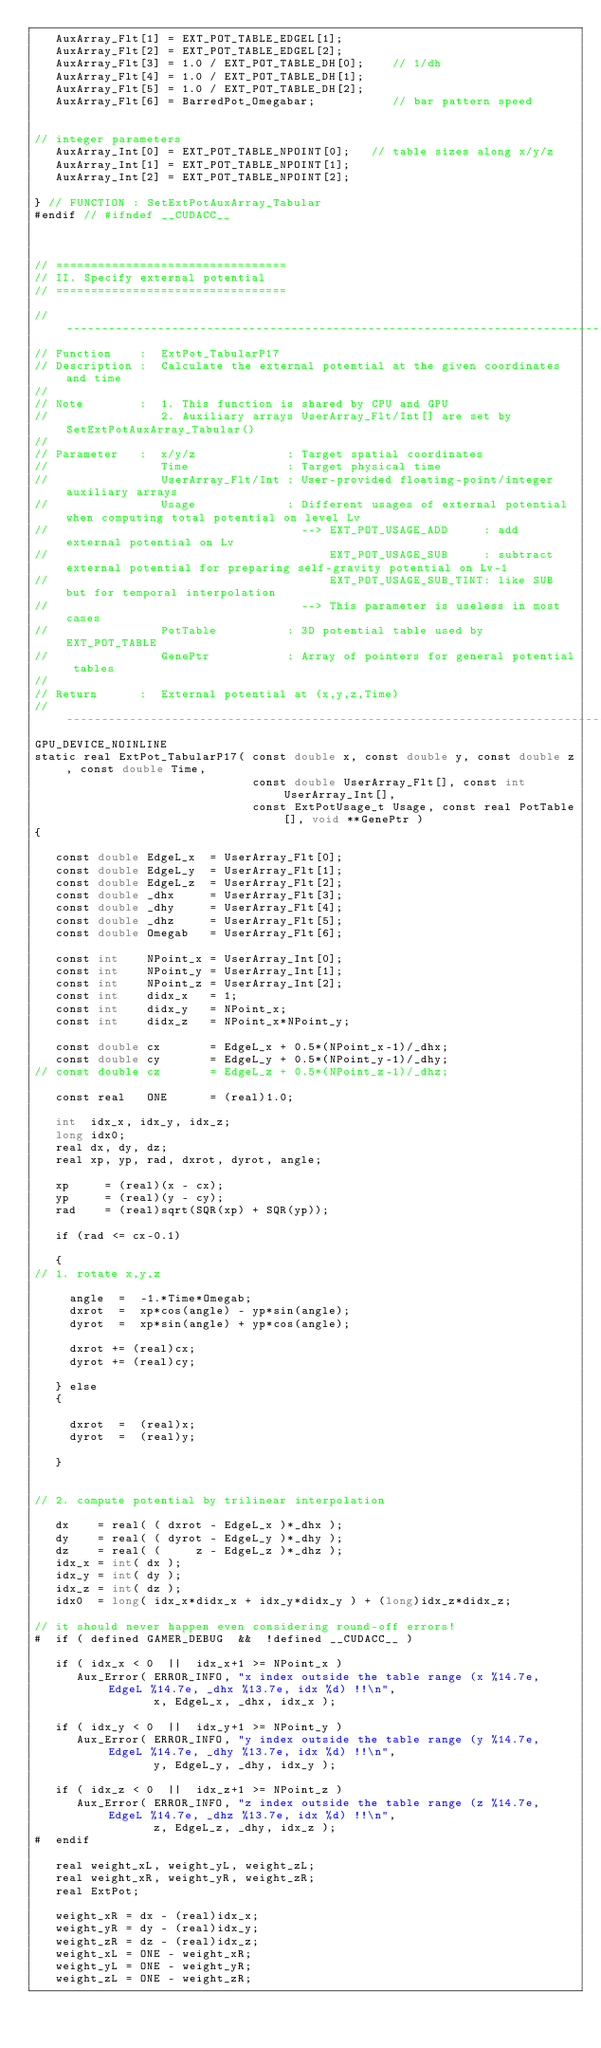Convert code to text. <code><loc_0><loc_0><loc_500><loc_500><_Cuda_>   AuxArray_Flt[1] = EXT_POT_TABLE_EDGEL[1];
   AuxArray_Flt[2] = EXT_POT_TABLE_EDGEL[2];
   AuxArray_Flt[3] = 1.0 / EXT_POT_TABLE_DH[0];    // 1/dh
   AuxArray_Flt[4] = 1.0 / EXT_POT_TABLE_DH[1];
   AuxArray_Flt[5] = 1.0 / EXT_POT_TABLE_DH[2];
   AuxArray_Flt[6] = BarredPot_Omegabar;           // bar pattern speed


// integer parameters
   AuxArray_Int[0] = EXT_POT_TABLE_NPOINT[0];   // table sizes along x/y/z
   AuxArray_Int[1] = EXT_POT_TABLE_NPOINT[1];
   AuxArray_Int[2] = EXT_POT_TABLE_NPOINT[2];

} // FUNCTION : SetExtPotAuxArray_Tabular
#endif // #ifndef __CUDACC__



// =================================
// II. Specify external potential
// =================================

//-----------------------------------------------------------------------------------------
// Function    :  ExtPot_TabularP17
// Description :  Calculate the external potential at the given coordinates and time
//
// Note        :  1. This function is shared by CPU and GPU
//                2. Auxiliary arrays UserArray_Flt/Int[] are set by SetExtPotAuxArray_Tabular()
//
// Parameter   :  x/y/z             : Target spatial coordinates
//                Time              : Target physical time
//                UserArray_Flt/Int : User-provided floating-point/integer auxiliary arrays
//                Usage             : Different usages of external potential when computing total potential on level Lv
//                                    --> EXT_POT_USAGE_ADD     : add external potential on Lv
//                                        EXT_POT_USAGE_SUB     : subtract external potential for preparing self-gravity potential on Lv-1
//                                        EXT_POT_USAGE_SUB_TINT: like SUB but for temporal interpolation
//                                    --> This parameter is useless in most cases
//                PotTable          : 3D potential table used by EXT_POT_TABLE
//                GenePtr           : Array of pointers for general potential tables
//
// Return      :  External potential at (x,y,z,Time)
//-----------------------------------------------------------------------------------------
GPU_DEVICE_NOINLINE
static real ExtPot_TabularP17( const double x, const double y, const double z, const double Time,
                               const double UserArray_Flt[], const int UserArray_Int[],
                               const ExtPotUsage_t Usage, const real PotTable[], void **GenePtr )
{

   const double EdgeL_x  = UserArray_Flt[0];
   const double EdgeL_y  = UserArray_Flt[1];
   const double EdgeL_z  = UserArray_Flt[2];
   const double _dhx     = UserArray_Flt[3];
   const double _dhy     = UserArray_Flt[4];
   const double _dhz     = UserArray_Flt[5];
   const double Omegab   = UserArray_Flt[6];

   const int    NPoint_x = UserArray_Int[0];
   const int    NPoint_y = UserArray_Int[1];
   const int    NPoint_z = UserArray_Int[2];
   const int    didx_x   = 1;
   const int    didx_y   = NPoint_x;
   const int    didx_z   = NPoint_x*NPoint_y;

   const double cx       = EdgeL_x + 0.5*(NPoint_x-1)/_dhx;
   const double cy       = EdgeL_y + 0.5*(NPoint_y-1)/_dhy;
// const double cz       = EdgeL_z + 0.5*(NPoint_z-1)/_dhz;

   const real   ONE      = (real)1.0;

   int  idx_x, idx_y, idx_z;
   long idx0;
   real dx, dy, dz;
   real xp, yp, rad, dxrot, dyrot, angle;

   xp     = (real)(x - cx);
   yp     = (real)(y - cy);
   rad    = (real)sqrt(SQR(xp) + SQR(yp));

   if (rad <= cx-0.1)

   {
// 1. rotate x,y,z

     angle  =  -1.*Time*Omegab;
     dxrot  =  xp*cos(angle) - yp*sin(angle);
     dyrot  =  xp*sin(angle) + yp*cos(angle);

     dxrot += (real)cx;
     dyrot += (real)cy;

   } else
   {

     dxrot  =  (real)x;
     dyrot  =  (real)y;

   }


// 2. compute potential by trilinear interpolation

   dx    = real( ( dxrot - EdgeL_x )*_dhx );
   dy    = real( ( dyrot - EdgeL_y )*_dhy );
   dz    = real( (     z - EdgeL_z )*_dhz );
   idx_x = int( dx );
   idx_y = int( dy );
   idx_z = int( dz );
   idx0  = long( idx_x*didx_x + idx_y*didx_y ) + (long)idx_z*didx_z;

// it should never happen even considering round-off errors!
#  if ( defined GAMER_DEBUG  &&  !defined __CUDACC__ )

   if ( idx_x < 0  ||  idx_x+1 >= NPoint_x )
      Aux_Error( ERROR_INFO, "x index outside the table range (x %14.7e, EdgeL %14.7e, _dhx %13.7e, idx %d) !!\n",
                 x, EdgeL_x, _dhx, idx_x );

   if ( idx_y < 0  ||  idx_y+1 >= NPoint_y )
      Aux_Error( ERROR_INFO, "y index outside the table range (y %14.7e, EdgeL %14.7e, _dhy %13.7e, idx %d) !!\n",
                 y, EdgeL_y, _dhy, idx_y );

   if ( idx_z < 0  ||  idx_z+1 >= NPoint_z )
      Aux_Error( ERROR_INFO, "z index outside the table range (z %14.7e, EdgeL %14.7e, _dhz %13.7e, idx %d) !!\n",
                 z, EdgeL_z, _dhy, idx_z );
#  endif

   real weight_xL, weight_yL, weight_zL;
   real weight_xR, weight_yR, weight_zR;
   real ExtPot;

   weight_xR = dx - (real)idx_x;
   weight_yR = dy - (real)idx_y;
   weight_zR = dz - (real)idx_z;
   weight_xL = ONE - weight_xR;
   weight_yL = ONE - weight_yR;
   weight_zL = ONE - weight_zR;
</code> 